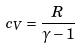Convert formula to latex. <formula><loc_0><loc_0><loc_500><loc_500>c _ { V } = \frac { R } { \gamma - 1 }</formula> 